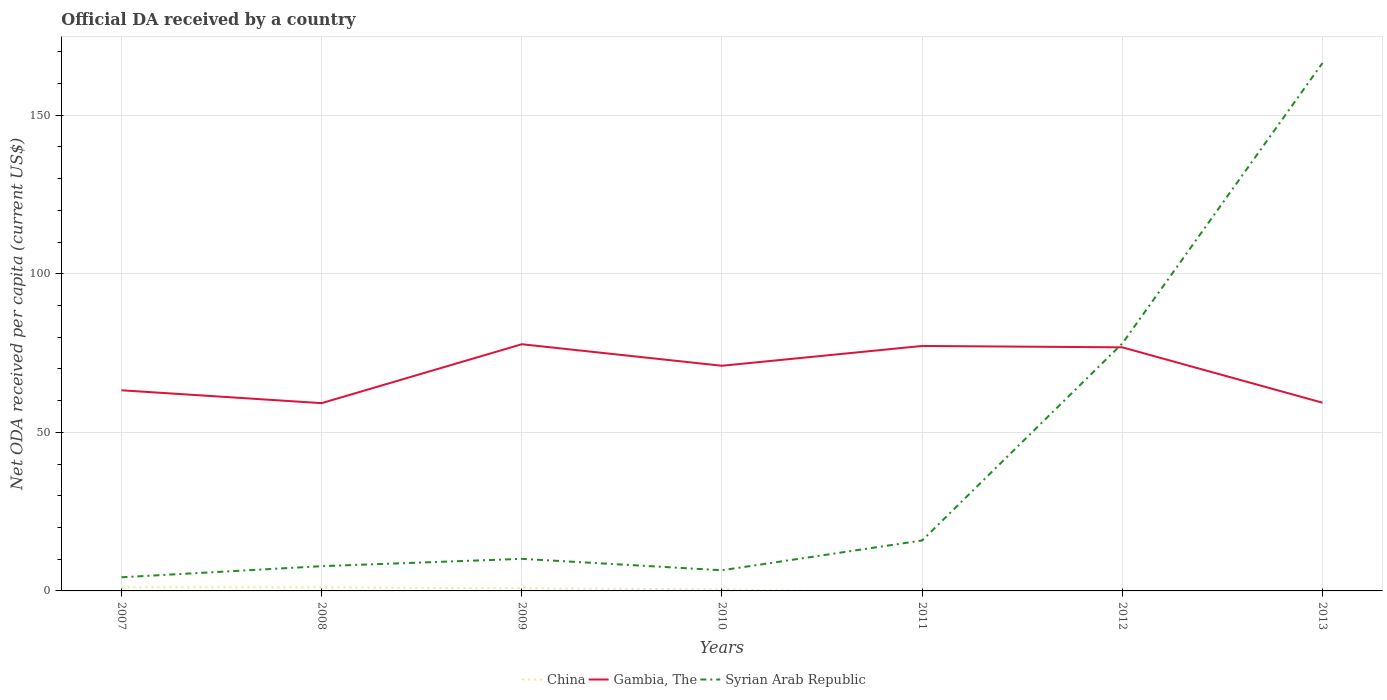What is the total ODA received in in Gambia, The in the graph?
Your answer should be very brief. -6.24. What is the difference between the highest and the second highest ODA received in in Gambia, The?
Offer a very short reply. 18.57. What is the difference between the highest and the lowest ODA received in in Gambia, The?
Your answer should be very brief. 4. How many lines are there?
Your response must be concise. 3. How many years are there in the graph?
Keep it short and to the point. 7. Are the values on the major ticks of Y-axis written in scientific E-notation?
Provide a short and direct response. No. How many legend labels are there?
Offer a terse response. 3. What is the title of the graph?
Your answer should be very brief. Official DA received by a country. What is the label or title of the Y-axis?
Ensure brevity in your answer.  Net ODA received per capita (current US$). What is the Net ODA received per capita (current US$) in China in 2007?
Provide a short and direct response. 1.13. What is the Net ODA received per capita (current US$) of Gambia, The in 2007?
Ensure brevity in your answer.  63.26. What is the Net ODA received per capita (current US$) of Syrian Arab Republic in 2007?
Your answer should be compact. 4.3. What is the Net ODA received per capita (current US$) in China in 2008?
Your answer should be compact. 1.12. What is the Net ODA received per capita (current US$) of Gambia, The in 2008?
Keep it short and to the point. 59.21. What is the Net ODA received per capita (current US$) of Syrian Arab Republic in 2008?
Provide a succinct answer. 7.8. What is the Net ODA received per capita (current US$) of China in 2009?
Your answer should be compact. 0.85. What is the Net ODA received per capita (current US$) in Gambia, The in 2009?
Make the answer very short. 77.78. What is the Net ODA received per capita (current US$) of Syrian Arab Republic in 2009?
Your answer should be compact. 10.12. What is the Net ODA received per capita (current US$) of China in 2010?
Provide a succinct answer. 0.48. What is the Net ODA received per capita (current US$) of Gambia, The in 2010?
Offer a terse response. 71. What is the Net ODA received per capita (current US$) of Syrian Arab Republic in 2010?
Offer a terse response. 6.52. What is the Net ODA received per capita (current US$) in Gambia, The in 2011?
Your answer should be compact. 77.24. What is the Net ODA received per capita (current US$) of Syrian Arab Republic in 2011?
Keep it short and to the point. 15.9. What is the Net ODA received per capita (current US$) in Gambia, The in 2012?
Provide a succinct answer. 76.81. What is the Net ODA received per capita (current US$) in Syrian Arab Republic in 2012?
Your answer should be very brief. 78.01. What is the Net ODA received per capita (current US$) of Gambia, The in 2013?
Provide a short and direct response. 59.35. What is the Net ODA received per capita (current US$) of Syrian Arab Republic in 2013?
Provide a short and direct response. 166.45. Across all years, what is the maximum Net ODA received per capita (current US$) of China?
Your response must be concise. 1.13. Across all years, what is the maximum Net ODA received per capita (current US$) in Gambia, The?
Make the answer very short. 77.78. Across all years, what is the maximum Net ODA received per capita (current US$) of Syrian Arab Republic?
Your response must be concise. 166.45. Across all years, what is the minimum Net ODA received per capita (current US$) of Gambia, The?
Your answer should be very brief. 59.21. Across all years, what is the minimum Net ODA received per capita (current US$) of Syrian Arab Republic?
Your response must be concise. 4.3. What is the total Net ODA received per capita (current US$) in China in the graph?
Offer a terse response. 3.58. What is the total Net ODA received per capita (current US$) of Gambia, The in the graph?
Your answer should be very brief. 484.65. What is the total Net ODA received per capita (current US$) of Syrian Arab Republic in the graph?
Offer a terse response. 289.09. What is the difference between the Net ODA received per capita (current US$) in China in 2007 and that in 2008?
Provide a short and direct response. 0.01. What is the difference between the Net ODA received per capita (current US$) in Gambia, The in 2007 and that in 2008?
Ensure brevity in your answer.  4.05. What is the difference between the Net ODA received per capita (current US$) of Syrian Arab Republic in 2007 and that in 2008?
Give a very brief answer. -3.5. What is the difference between the Net ODA received per capita (current US$) of China in 2007 and that in 2009?
Your answer should be very brief. 0.28. What is the difference between the Net ODA received per capita (current US$) of Gambia, The in 2007 and that in 2009?
Make the answer very short. -14.52. What is the difference between the Net ODA received per capita (current US$) in Syrian Arab Republic in 2007 and that in 2009?
Offer a terse response. -5.82. What is the difference between the Net ODA received per capita (current US$) in China in 2007 and that in 2010?
Ensure brevity in your answer.  0.65. What is the difference between the Net ODA received per capita (current US$) of Gambia, The in 2007 and that in 2010?
Keep it short and to the point. -7.73. What is the difference between the Net ODA received per capita (current US$) of Syrian Arab Republic in 2007 and that in 2010?
Make the answer very short. -2.21. What is the difference between the Net ODA received per capita (current US$) in Gambia, The in 2007 and that in 2011?
Offer a very short reply. -13.98. What is the difference between the Net ODA received per capita (current US$) in Syrian Arab Republic in 2007 and that in 2011?
Offer a very short reply. -11.6. What is the difference between the Net ODA received per capita (current US$) of Gambia, The in 2007 and that in 2012?
Offer a very short reply. -13.54. What is the difference between the Net ODA received per capita (current US$) of Syrian Arab Republic in 2007 and that in 2012?
Your response must be concise. -73.71. What is the difference between the Net ODA received per capita (current US$) in Gambia, The in 2007 and that in 2013?
Your response must be concise. 3.91. What is the difference between the Net ODA received per capita (current US$) in Syrian Arab Republic in 2007 and that in 2013?
Your response must be concise. -162.15. What is the difference between the Net ODA received per capita (current US$) in China in 2008 and that in 2009?
Offer a terse response. 0.27. What is the difference between the Net ODA received per capita (current US$) in Gambia, The in 2008 and that in 2009?
Keep it short and to the point. -18.57. What is the difference between the Net ODA received per capita (current US$) of Syrian Arab Republic in 2008 and that in 2009?
Offer a very short reply. -2.32. What is the difference between the Net ODA received per capita (current US$) in China in 2008 and that in 2010?
Provide a short and direct response. 0.63. What is the difference between the Net ODA received per capita (current US$) of Gambia, The in 2008 and that in 2010?
Your answer should be very brief. -11.79. What is the difference between the Net ODA received per capita (current US$) in Syrian Arab Republic in 2008 and that in 2010?
Your answer should be very brief. 1.28. What is the difference between the Net ODA received per capita (current US$) of Gambia, The in 2008 and that in 2011?
Make the answer very short. -18.03. What is the difference between the Net ODA received per capita (current US$) in Syrian Arab Republic in 2008 and that in 2011?
Provide a short and direct response. -8.1. What is the difference between the Net ODA received per capita (current US$) in Gambia, The in 2008 and that in 2012?
Your answer should be compact. -17.6. What is the difference between the Net ODA received per capita (current US$) in Syrian Arab Republic in 2008 and that in 2012?
Ensure brevity in your answer.  -70.21. What is the difference between the Net ODA received per capita (current US$) in Gambia, The in 2008 and that in 2013?
Your answer should be very brief. -0.14. What is the difference between the Net ODA received per capita (current US$) in Syrian Arab Republic in 2008 and that in 2013?
Keep it short and to the point. -158.65. What is the difference between the Net ODA received per capita (current US$) in China in 2009 and that in 2010?
Make the answer very short. 0.37. What is the difference between the Net ODA received per capita (current US$) in Gambia, The in 2009 and that in 2010?
Give a very brief answer. 6.79. What is the difference between the Net ODA received per capita (current US$) of Syrian Arab Republic in 2009 and that in 2010?
Ensure brevity in your answer.  3.6. What is the difference between the Net ODA received per capita (current US$) of Gambia, The in 2009 and that in 2011?
Make the answer very short. 0.54. What is the difference between the Net ODA received per capita (current US$) of Syrian Arab Republic in 2009 and that in 2011?
Offer a terse response. -5.79. What is the difference between the Net ODA received per capita (current US$) in Gambia, The in 2009 and that in 2012?
Keep it short and to the point. 0.98. What is the difference between the Net ODA received per capita (current US$) in Syrian Arab Republic in 2009 and that in 2012?
Give a very brief answer. -67.89. What is the difference between the Net ODA received per capita (current US$) of Gambia, The in 2009 and that in 2013?
Make the answer very short. 18.43. What is the difference between the Net ODA received per capita (current US$) of Syrian Arab Republic in 2009 and that in 2013?
Your response must be concise. -156.33. What is the difference between the Net ODA received per capita (current US$) of Gambia, The in 2010 and that in 2011?
Offer a very short reply. -6.24. What is the difference between the Net ODA received per capita (current US$) of Syrian Arab Republic in 2010 and that in 2011?
Keep it short and to the point. -9.39. What is the difference between the Net ODA received per capita (current US$) in Gambia, The in 2010 and that in 2012?
Ensure brevity in your answer.  -5.81. What is the difference between the Net ODA received per capita (current US$) in Syrian Arab Republic in 2010 and that in 2012?
Your response must be concise. -71.49. What is the difference between the Net ODA received per capita (current US$) in Gambia, The in 2010 and that in 2013?
Your response must be concise. 11.65. What is the difference between the Net ODA received per capita (current US$) in Syrian Arab Republic in 2010 and that in 2013?
Keep it short and to the point. -159.93. What is the difference between the Net ODA received per capita (current US$) in Gambia, The in 2011 and that in 2012?
Provide a short and direct response. 0.43. What is the difference between the Net ODA received per capita (current US$) of Syrian Arab Republic in 2011 and that in 2012?
Make the answer very short. -62.1. What is the difference between the Net ODA received per capita (current US$) in Gambia, The in 2011 and that in 2013?
Your answer should be compact. 17.89. What is the difference between the Net ODA received per capita (current US$) of Syrian Arab Republic in 2011 and that in 2013?
Offer a very short reply. -150.54. What is the difference between the Net ODA received per capita (current US$) in Gambia, The in 2012 and that in 2013?
Ensure brevity in your answer.  17.46. What is the difference between the Net ODA received per capita (current US$) in Syrian Arab Republic in 2012 and that in 2013?
Give a very brief answer. -88.44. What is the difference between the Net ODA received per capita (current US$) in China in 2007 and the Net ODA received per capita (current US$) in Gambia, The in 2008?
Give a very brief answer. -58.08. What is the difference between the Net ODA received per capita (current US$) of China in 2007 and the Net ODA received per capita (current US$) of Syrian Arab Republic in 2008?
Provide a succinct answer. -6.67. What is the difference between the Net ODA received per capita (current US$) of Gambia, The in 2007 and the Net ODA received per capita (current US$) of Syrian Arab Republic in 2008?
Offer a very short reply. 55.46. What is the difference between the Net ODA received per capita (current US$) of China in 2007 and the Net ODA received per capita (current US$) of Gambia, The in 2009?
Your response must be concise. -76.65. What is the difference between the Net ODA received per capita (current US$) in China in 2007 and the Net ODA received per capita (current US$) in Syrian Arab Republic in 2009?
Give a very brief answer. -8.99. What is the difference between the Net ODA received per capita (current US$) in Gambia, The in 2007 and the Net ODA received per capita (current US$) in Syrian Arab Republic in 2009?
Your response must be concise. 53.15. What is the difference between the Net ODA received per capita (current US$) of China in 2007 and the Net ODA received per capita (current US$) of Gambia, The in 2010?
Provide a succinct answer. -69.87. What is the difference between the Net ODA received per capita (current US$) in China in 2007 and the Net ODA received per capita (current US$) in Syrian Arab Republic in 2010?
Keep it short and to the point. -5.39. What is the difference between the Net ODA received per capita (current US$) in Gambia, The in 2007 and the Net ODA received per capita (current US$) in Syrian Arab Republic in 2010?
Give a very brief answer. 56.75. What is the difference between the Net ODA received per capita (current US$) in China in 2007 and the Net ODA received per capita (current US$) in Gambia, The in 2011?
Your answer should be compact. -76.11. What is the difference between the Net ODA received per capita (current US$) in China in 2007 and the Net ODA received per capita (current US$) in Syrian Arab Republic in 2011?
Your answer should be very brief. -14.78. What is the difference between the Net ODA received per capita (current US$) in Gambia, The in 2007 and the Net ODA received per capita (current US$) in Syrian Arab Republic in 2011?
Make the answer very short. 47.36. What is the difference between the Net ODA received per capita (current US$) of China in 2007 and the Net ODA received per capita (current US$) of Gambia, The in 2012?
Keep it short and to the point. -75.68. What is the difference between the Net ODA received per capita (current US$) in China in 2007 and the Net ODA received per capita (current US$) in Syrian Arab Republic in 2012?
Make the answer very short. -76.88. What is the difference between the Net ODA received per capita (current US$) of Gambia, The in 2007 and the Net ODA received per capita (current US$) of Syrian Arab Republic in 2012?
Your answer should be very brief. -14.75. What is the difference between the Net ODA received per capita (current US$) of China in 2007 and the Net ODA received per capita (current US$) of Gambia, The in 2013?
Ensure brevity in your answer.  -58.22. What is the difference between the Net ODA received per capita (current US$) of China in 2007 and the Net ODA received per capita (current US$) of Syrian Arab Republic in 2013?
Your answer should be compact. -165.32. What is the difference between the Net ODA received per capita (current US$) in Gambia, The in 2007 and the Net ODA received per capita (current US$) in Syrian Arab Republic in 2013?
Ensure brevity in your answer.  -103.18. What is the difference between the Net ODA received per capita (current US$) of China in 2008 and the Net ODA received per capita (current US$) of Gambia, The in 2009?
Your answer should be compact. -76.67. What is the difference between the Net ODA received per capita (current US$) in China in 2008 and the Net ODA received per capita (current US$) in Syrian Arab Republic in 2009?
Make the answer very short. -9. What is the difference between the Net ODA received per capita (current US$) of Gambia, The in 2008 and the Net ODA received per capita (current US$) of Syrian Arab Republic in 2009?
Ensure brevity in your answer.  49.09. What is the difference between the Net ODA received per capita (current US$) in China in 2008 and the Net ODA received per capita (current US$) in Gambia, The in 2010?
Your response must be concise. -69.88. What is the difference between the Net ODA received per capita (current US$) in China in 2008 and the Net ODA received per capita (current US$) in Syrian Arab Republic in 2010?
Provide a succinct answer. -5.4. What is the difference between the Net ODA received per capita (current US$) in Gambia, The in 2008 and the Net ODA received per capita (current US$) in Syrian Arab Republic in 2010?
Give a very brief answer. 52.69. What is the difference between the Net ODA received per capita (current US$) of China in 2008 and the Net ODA received per capita (current US$) of Gambia, The in 2011?
Offer a very short reply. -76.12. What is the difference between the Net ODA received per capita (current US$) of China in 2008 and the Net ODA received per capita (current US$) of Syrian Arab Republic in 2011?
Ensure brevity in your answer.  -14.79. What is the difference between the Net ODA received per capita (current US$) in Gambia, The in 2008 and the Net ODA received per capita (current US$) in Syrian Arab Republic in 2011?
Provide a succinct answer. 43.3. What is the difference between the Net ODA received per capita (current US$) in China in 2008 and the Net ODA received per capita (current US$) in Gambia, The in 2012?
Your answer should be compact. -75.69. What is the difference between the Net ODA received per capita (current US$) in China in 2008 and the Net ODA received per capita (current US$) in Syrian Arab Republic in 2012?
Make the answer very short. -76.89. What is the difference between the Net ODA received per capita (current US$) of Gambia, The in 2008 and the Net ODA received per capita (current US$) of Syrian Arab Republic in 2012?
Provide a short and direct response. -18.8. What is the difference between the Net ODA received per capita (current US$) of China in 2008 and the Net ODA received per capita (current US$) of Gambia, The in 2013?
Your answer should be compact. -58.23. What is the difference between the Net ODA received per capita (current US$) of China in 2008 and the Net ODA received per capita (current US$) of Syrian Arab Republic in 2013?
Make the answer very short. -165.33. What is the difference between the Net ODA received per capita (current US$) in Gambia, The in 2008 and the Net ODA received per capita (current US$) in Syrian Arab Republic in 2013?
Your answer should be compact. -107.24. What is the difference between the Net ODA received per capita (current US$) in China in 2009 and the Net ODA received per capita (current US$) in Gambia, The in 2010?
Make the answer very short. -70.15. What is the difference between the Net ODA received per capita (current US$) of China in 2009 and the Net ODA received per capita (current US$) of Syrian Arab Republic in 2010?
Your answer should be compact. -5.67. What is the difference between the Net ODA received per capita (current US$) in Gambia, The in 2009 and the Net ODA received per capita (current US$) in Syrian Arab Republic in 2010?
Offer a very short reply. 71.27. What is the difference between the Net ODA received per capita (current US$) of China in 2009 and the Net ODA received per capita (current US$) of Gambia, The in 2011?
Your answer should be very brief. -76.39. What is the difference between the Net ODA received per capita (current US$) of China in 2009 and the Net ODA received per capita (current US$) of Syrian Arab Republic in 2011?
Provide a succinct answer. -15.06. What is the difference between the Net ODA received per capita (current US$) of Gambia, The in 2009 and the Net ODA received per capita (current US$) of Syrian Arab Republic in 2011?
Your answer should be very brief. 61.88. What is the difference between the Net ODA received per capita (current US$) of China in 2009 and the Net ODA received per capita (current US$) of Gambia, The in 2012?
Provide a short and direct response. -75.96. What is the difference between the Net ODA received per capita (current US$) in China in 2009 and the Net ODA received per capita (current US$) in Syrian Arab Republic in 2012?
Your answer should be very brief. -77.16. What is the difference between the Net ODA received per capita (current US$) in Gambia, The in 2009 and the Net ODA received per capita (current US$) in Syrian Arab Republic in 2012?
Your answer should be compact. -0.23. What is the difference between the Net ODA received per capita (current US$) in China in 2009 and the Net ODA received per capita (current US$) in Gambia, The in 2013?
Make the answer very short. -58.5. What is the difference between the Net ODA received per capita (current US$) of China in 2009 and the Net ODA received per capita (current US$) of Syrian Arab Republic in 2013?
Make the answer very short. -165.6. What is the difference between the Net ODA received per capita (current US$) of Gambia, The in 2009 and the Net ODA received per capita (current US$) of Syrian Arab Republic in 2013?
Your answer should be very brief. -88.66. What is the difference between the Net ODA received per capita (current US$) in China in 2010 and the Net ODA received per capita (current US$) in Gambia, The in 2011?
Your answer should be very brief. -76.76. What is the difference between the Net ODA received per capita (current US$) in China in 2010 and the Net ODA received per capita (current US$) in Syrian Arab Republic in 2011?
Make the answer very short. -15.42. What is the difference between the Net ODA received per capita (current US$) in Gambia, The in 2010 and the Net ODA received per capita (current US$) in Syrian Arab Republic in 2011?
Provide a succinct answer. 55.09. What is the difference between the Net ODA received per capita (current US$) of China in 2010 and the Net ODA received per capita (current US$) of Gambia, The in 2012?
Your answer should be very brief. -76.32. What is the difference between the Net ODA received per capita (current US$) in China in 2010 and the Net ODA received per capita (current US$) in Syrian Arab Republic in 2012?
Keep it short and to the point. -77.53. What is the difference between the Net ODA received per capita (current US$) of Gambia, The in 2010 and the Net ODA received per capita (current US$) of Syrian Arab Republic in 2012?
Make the answer very short. -7.01. What is the difference between the Net ODA received per capita (current US$) in China in 2010 and the Net ODA received per capita (current US$) in Gambia, The in 2013?
Make the answer very short. -58.87. What is the difference between the Net ODA received per capita (current US$) of China in 2010 and the Net ODA received per capita (current US$) of Syrian Arab Republic in 2013?
Your response must be concise. -165.96. What is the difference between the Net ODA received per capita (current US$) of Gambia, The in 2010 and the Net ODA received per capita (current US$) of Syrian Arab Republic in 2013?
Your answer should be compact. -95.45. What is the difference between the Net ODA received per capita (current US$) in Gambia, The in 2011 and the Net ODA received per capita (current US$) in Syrian Arab Republic in 2012?
Provide a succinct answer. -0.77. What is the difference between the Net ODA received per capita (current US$) of Gambia, The in 2011 and the Net ODA received per capita (current US$) of Syrian Arab Republic in 2013?
Make the answer very short. -89.21. What is the difference between the Net ODA received per capita (current US$) of Gambia, The in 2012 and the Net ODA received per capita (current US$) of Syrian Arab Republic in 2013?
Your response must be concise. -89.64. What is the average Net ODA received per capita (current US$) in China per year?
Keep it short and to the point. 0.51. What is the average Net ODA received per capita (current US$) in Gambia, The per year?
Ensure brevity in your answer.  69.24. What is the average Net ODA received per capita (current US$) in Syrian Arab Republic per year?
Provide a short and direct response. 41.3. In the year 2007, what is the difference between the Net ODA received per capita (current US$) in China and Net ODA received per capita (current US$) in Gambia, The?
Keep it short and to the point. -62.13. In the year 2007, what is the difference between the Net ODA received per capita (current US$) in China and Net ODA received per capita (current US$) in Syrian Arab Republic?
Provide a short and direct response. -3.17. In the year 2007, what is the difference between the Net ODA received per capita (current US$) in Gambia, The and Net ODA received per capita (current US$) in Syrian Arab Republic?
Your answer should be compact. 58.96. In the year 2008, what is the difference between the Net ODA received per capita (current US$) of China and Net ODA received per capita (current US$) of Gambia, The?
Give a very brief answer. -58.09. In the year 2008, what is the difference between the Net ODA received per capita (current US$) in China and Net ODA received per capita (current US$) in Syrian Arab Republic?
Your answer should be very brief. -6.68. In the year 2008, what is the difference between the Net ODA received per capita (current US$) in Gambia, The and Net ODA received per capita (current US$) in Syrian Arab Republic?
Provide a short and direct response. 51.41. In the year 2009, what is the difference between the Net ODA received per capita (current US$) in China and Net ODA received per capita (current US$) in Gambia, The?
Your response must be concise. -76.94. In the year 2009, what is the difference between the Net ODA received per capita (current US$) in China and Net ODA received per capita (current US$) in Syrian Arab Republic?
Your answer should be compact. -9.27. In the year 2009, what is the difference between the Net ODA received per capita (current US$) in Gambia, The and Net ODA received per capita (current US$) in Syrian Arab Republic?
Your answer should be very brief. 67.67. In the year 2010, what is the difference between the Net ODA received per capita (current US$) of China and Net ODA received per capita (current US$) of Gambia, The?
Offer a terse response. -70.52. In the year 2010, what is the difference between the Net ODA received per capita (current US$) in China and Net ODA received per capita (current US$) in Syrian Arab Republic?
Ensure brevity in your answer.  -6.03. In the year 2010, what is the difference between the Net ODA received per capita (current US$) of Gambia, The and Net ODA received per capita (current US$) of Syrian Arab Republic?
Make the answer very short. 64.48. In the year 2011, what is the difference between the Net ODA received per capita (current US$) in Gambia, The and Net ODA received per capita (current US$) in Syrian Arab Republic?
Your answer should be very brief. 61.33. In the year 2012, what is the difference between the Net ODA received per capita (current US$) in Gambia, The and Net ODA received per capita (current US$) in Syrian Arab Republic?
Your answer should be compact. -1.2. In the year 2013, what is the difference between the Net ODA received per capita (current US$) of Gambia, The and Net ODA received per capita (current US$) of Syrian Arab Republic?
Ensure brevity in your answer.  -107.1. What is the ratio of the Net ODA received per capita (current US$) of China in 2007 to that in 2008?
Offer a very short reply. 1.01. What is the ratio of the Net ODA received per capita (current US$) in Gambia, The in 2007 to that in 2008?
Give a very brief answer. 1.07. What is the ratio of the Net ODA received per capita (current US$) of Syrian Arab Republic in 2007 to that in 2008?
Your response must be concise. 0.55. What is the ratio of the Net ODA received per capita (current US$) of China in 2007 to that in 2009?
Ensure brevity in your answer.  1.33. What is the ratio of the Net ODA received per capita (current US$) in Gambia, The in 2007 to that in 2009?
Your response must be concise. 0.81. What is the ratio of the Net ODA received per capita (current US$) of Syrian Arab Republic in 2007 to that in 2009?
Provide a succinct answer. 0.43. What is the ratio of the Net ODA received per capita (current US$) of China in 2007 to that in 2010?
Your answer should be very brief. 2.34. What is the ratio of the Net ODA received per capita (current US$) of Gambia, The in 2007 to that in 2010?
Provide a short and direct response. 0.89. What is the ratio of the Net ODA received per capita (current US$) of Syrian Arab Republic in 2007 to that in 2010?
Provide a succinct answer. 0.66. What is the ratio of the Net ODA received per capita (current US$) in Gambia, The in 2007 to that in 2011?
Provide a succinct answer. 0.82. What is the ratio of the Net ODA received per capita (current US$) of Syrian Arab Republic in 2007 to that in 2011?
Make the answer very short. 0.27. What is the ratio of the Net ODA received per capita (current US$) of Gambia, The in 2007 to that in 2012?
Ensure brevity in your answer.  0.82. What is the ratio of the Net ODA received per capita (current US$) in Syrian Arab Republic in 2007 to that in 2012?
Your answer should be compact. 0.06. What is the ratio of the Net ODA received per capita (current US$) of Gambia, The in 2007 to that in 2013?
Make the answer very short. 1.07. What is the ratio of the Net ODA received per capita (current US$) of Syrian Arab Republic in 2007 to that in 2013?
Your answer should be very brief. 0.03. What is the ratio of the Net ODA received per capita (current US$) of China in 2008 to that in 2009?
Ensure brevity in your answer.  1.32. What is the ratio of the Net ODA received per capita (current US$) of Gambia, The in 2008 to that in 2009?
Your answer should be very brief. 0.76. What is the ratio of the Net ODA received per capita (current US$) in Syrian Arab Republic in 2008 to that in 2009?
Your answer should be compact. 0.77. What is the ratio of the Net ODA received per capita (current US$) in China in 2008 to that in 2010?
Make the answer very short. 2.31. What is the ratio of the Net ODA received per capita (current US$) in Gambia, The in 2008 to that in 2010?
Make the answer very short. 0.83. What is the ratio of the Net ODA received per capita (current US$) in Syrian Arab Republic in 2008 to that in 2010?
Keep it short and to the point. 1.2. What is the ratio of the Net ODA received per capita (current US$) in Gambia, The in 2008 to that in 2011?
Make the answer very short. 0.77. What is the ratio of the Net ODA received per capita (current US$) of Syrian Arab Republic in 2008 to that in 2011?
Your answer should be compact. 0.49. What is the ratio of the Net ODA received per capita (current US$) in Gambia, The in 2008 to that in 2012?
Make the answer very short. 0.77. What is the ratio of the Net ODA received per capita (current US$) in Syrian Arab Republic in 2008 to that in 2012?
Give a very brief answer. 0.1. What is the ratio of the Net ODA received per capita (current US$) of Syrian Arab Republic in 2008 to that in 2013?
Provide a succinct answer. 0.05. What is the ratio of the Net ODA received per capita (current US$) of China in 2009 to that in 2010?
Ensure brevity in your answer.  1.76. What is the ratio of the Net ODA received per capita (current US$) of Gambia, The in 2009 to that in 2010?
Provide a short and direct response. 1.1. What is the ratio of the Net ODA received per capita (current US$) of Syrian Arab Republic in 2009 to that in 2010?
Your answer should be very brief. 1.55. What is the ratio of the Net ODA received per capita (current US$) of Gambia, The in 2009 to that in 2011?
Provide a succinct answer. 1.01. What is the ratio of the Net ODA received per capita (current US$) of Syrian Arab Republic in 2009 to that in 2011?
Offer a terse response. 0.64. What is the ratio of the Net ODA received per capita (current US$) in Gambia, The in 2009 to that in 2012?
Provide a succinct answer. 1.01. What is the ratio of the Net ODA received per capita (current US$) in Syrian Arab Republic in 2009 to that in 2012?
Offer a very short reply. 0.13. What is the ratio of the Net ODA received per capita (current US$) of Gambia, The in 2009 to that in 2013?
Provide a succinct answer. 1.31. What is the ratio of the Net ODA received per capita (current US$) of Syrian Arab Republic in 2009 to that in 2013?
Give a very brief answer. 0.06. What is the ratio of the Net ODA received per capita (current US$) in Gambia, The in 2010 to that in 2011?
Your answer should be very brief. 0.92. What is the ratio of the Net ODA received per capita (current US$) of Syrian Arab Republic in 2010 to that in 2011?
Ensure brevity in your answer.  0.41. What is the ratio of the Net ODA received per capita (current US$) in Gambia, The in 2010 to that in 2012?
Offer a very short reply. 0.92. What is the ratio of the Net ODA received per capita (current US$) in Syrian Arab Republic in 2010 to that in 2012?
Your answer should be compact. 0.08. What is the ratio of the Net ODA received per capita (current US$) in Gambia, The in 2010 to that in 2013?
Provide a succinct answer. 1.2. What is the ratio of the Net ODA received per capita (current US$) in Syrian Arab Republic in 2010 to that in 2013?
Your response must be concise. 0.04. What is the ratio of the Net ODA received per capita (current US$) of Gambia, The in 2011 to that in 2012?
Provide a succinct answer. 1.01. What is the ratio of the Net ODA received per capita (current US$) of Syrian Arab Republic in 2011 to that in 2012?
Your answer should be compact. 0.2. What is the ratio of the Net ODA received per capita (current US$) of Gambia, The in 2011 to that in 2013?
Give a very brief answer. 1.3. What is the ratio of the Net ODA received per capita (current US$) of Syrian Arab Republic in 2011 to that in 2013?
Ensure brevity in your answer.  0.1. What is the ratio of the Net ODA received per capita (current US$) in Gambia, The in 2012 to that in 2013?
Your answer should be compact. 1.29. What is the ratio of the Net ODA received per capita (current US$) in Syrian Arab Republic in 2012 to that in 2013?
Give a very brief answer. 0.47. What is the difference between the highest and the second highest Net ODA received per capita (current US$) of China?
Ensure brevity in your answer.  0.01. What is the difference between the highest and the second highest Net ODA received per capita (current US$) in Gambia, The?
Make the answer very short. 0.54. What is the difference between the highest and the second highest Net ODA received per capita (current US$) of Syrian Arab Republic?
Your answer should be very brief. 88.44. What is the difference between the highest and the lowest Net ODA received per capita (current US$) in China?
Your response must be concise. 1.13. What is the difference between the highest and the lowest Net ODA received per capita (current US$) in Gambia, The?
Ensure brevity in your answer.  18.57. What is the difference between the highest and the lowest Net ODA received per capita (current US$) in Syrian Arab Republic?
Provide a succinct answer. 162.15. 